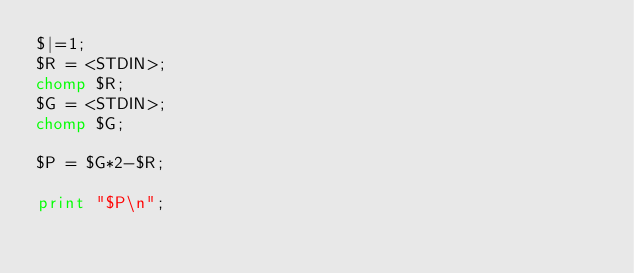<code> <loc_0><loc_0><loc_500><loc_500><_Perl_>$|=1;
$R = <STDIN>;
chomp $R;
$G = <STDIN>;
chomp $G;

$P = $G*2-$R;

print "$P\n";
</code> 